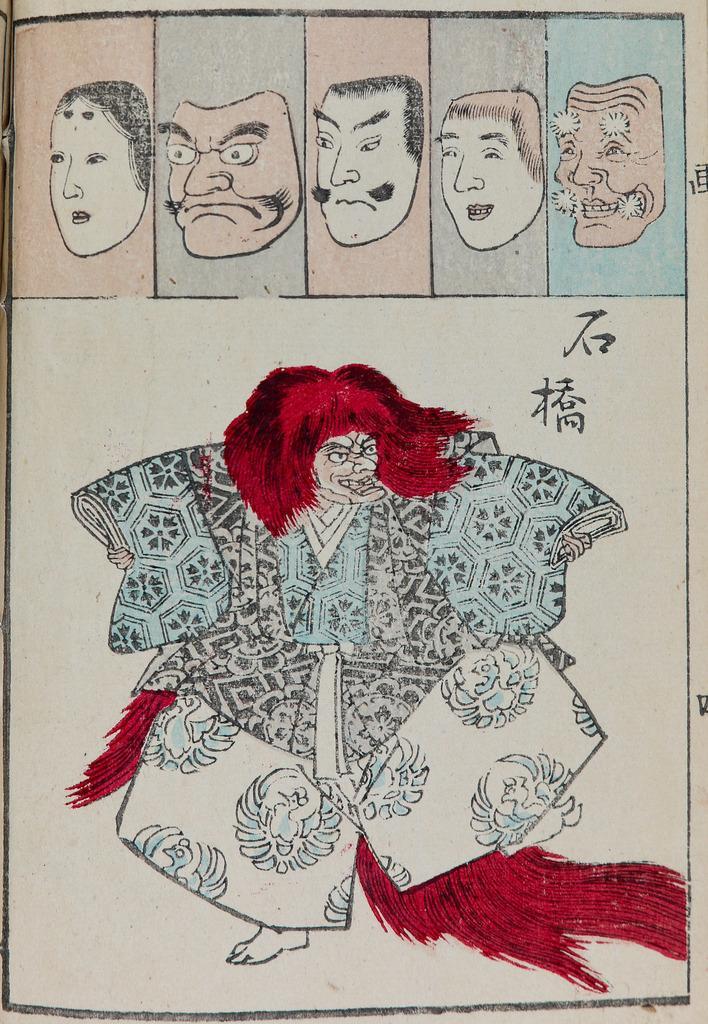Describe this image in one or two sentences. In this image we can see a poster. On this poster we can see pictures. 